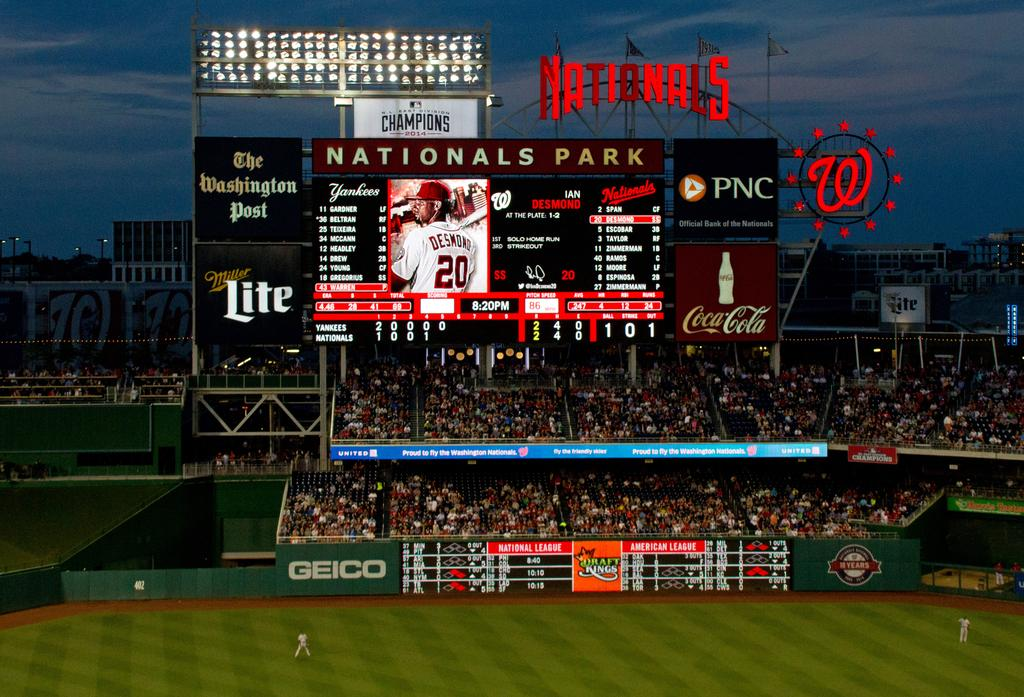<image>
Provide a brief description of the given image. A Nationals Park scoreboard with advertisements for Coca Cola, Miller lite, and PNC. 